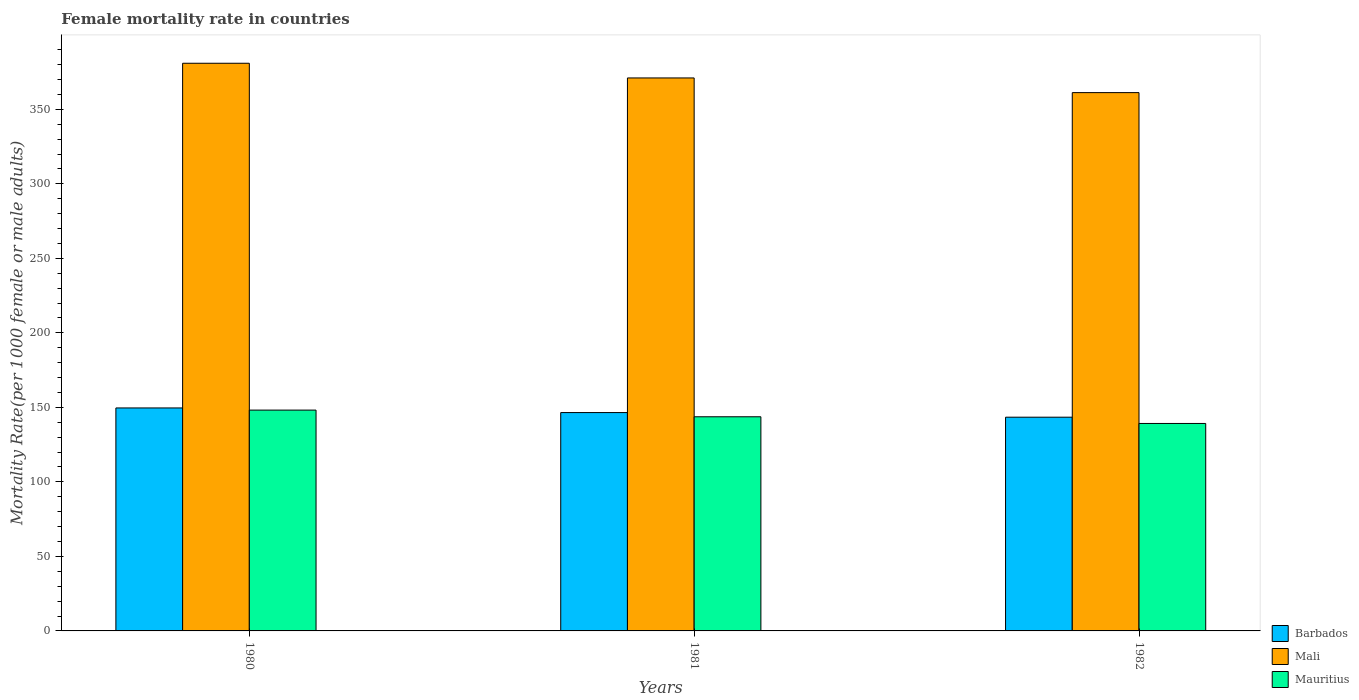How many different coloured bars are there?
Provide a short and direct response. 3. How many groups of bars are there?
Offer a very short reply. 3. How many bars are there on the 2nd tick from the left?
Your response must be concise. 3. How many bars are there on the 2nd tick from the right?
Make the answer very short. 3. What is the label of the 3rd group of bars from the left?
Your response must be concise. 1982. In how many cases, is the number of bars for a given year not equal to the number of legend labels?
Provide a short and direct response. 0. What is the female mortality rate in Mali in 1982?
Your response must be concise. 361.18. Across all years, what is the maximum female mortality rate in Mali?
Ensure brevity in your answer.  380.89. Across all years, what is the minimum female mortality rate in Mali?
Your answer should be compact. 361.18. In which year was the female mortality rate in Mauritius maximum?
Your answer should be compact. 1980. What is the total female mortality rate in Mauritius in the graph?
Make the answer very short. 431.06. What is the difference between the female mortality rate in Mauritius in 1981 and that in 1982?
Keep it short and to the point. 4.48. What is the difference between the female mortality rate in Barbados in 1981 and the female mortality rate in Mali in 1982?
Offer a very short reply. -214.67. What is the average female mortality rate in Mali per year?
Give a very brief answer. 371.04. In the year 1980, what is the difference between the female mortality rate in Barbados and female mortality rate in Mali?
Make the answer very short. -231.28. In how many years, is the female mortality rate in Mali greater than 10?
Offer a terse response. 3. What is the ratio of the female mortality rate in Mali in 1980 to that in 1981?
Provide a succinct answer. 1.03. Is the female mortality rate in Mauritius in 1980 less than that in 1982?
Offer a terse response. No. What is the difference between the highest and the second highest female mortality rate in Mauritius?
Your response must be concise. 4.48. What is the difference between the highest and the lowest female mortality rate in Mauritius?
Offer a terse response. 8.96. In how many years, is the female mortality rate in Mauritius greater than the average female mortality rate in Mauritius taken over all years?
Make the answer very short. 1. What does the 2nd bar from the left in 1981 represents?
Offer a terse response. Mali. What does the 3rd bar from the right in 1981 represents?
Keep it short and to the point. Barbados. Are all the bars in the graph horizontal?
Make the answer very short. No. How many years are there in the graph?
Your answer should be very brief. 3. What is the difference between two consecutive major ticks on the Y-axis?
Provide a short and direct response. 50. Are the values on the major ticks of Y-axis written in scientific E-notation?
Provide a short and direct response. No. Does the graph contain any zero values?
Offer a terse response. No. Where does the legend appear in the graph?
Offer a terse response. Bottom right. How are the legend labels stacked?
Your answer should be very brief. Vertical. What is the title of the graph?
Provide a short and direct response. Female mortality rate in countries. What is the label or title of the Y-axis?
Your answer should be compact. Mortality Rate(per 1000 female or male adults). What is the Mortality Rate(per 1000 female or male adults) of Barbados in 1980?
Provide a short and direct response. 149.61. What is the Mortality Rate(per 1000 female or male adults) in Mali in 1980?
Provide a succinct answer. 380.89. What is the Mortality Rate(per 1000 female or male adults) of Mauritius in 1980?
Keep it short and to the point. 148.17. What is the Mortality Rate(per 1000 female or male adults) of Barbados in 1981?
Keep it short and to the point. 146.51. What is the Mortality Rate(per 1000 female or male adults) of Mali in 1981?
Offer a terse response. 371.04. What is the Mortality Rate(per 1000 female or male adults) of Mauritius in 1981?
Offer a terse response. 143.69. What is the Mortality Rate(per 1000 female or male adults) in Barbados in 1982?
Make the answer very short. 143.4. What is the Mortality Rate(per 1000 female or male adults) in Mali in 1982?
Make the answer very short. 361.18. What is the Mortality Rate(per 1000 female or male adults) of Mauritius in 1982?
Your answer should be compact. 139.2. Across all years, what is the maximum Mortality Rate(per 1000 female or male adults) in Barbados?
Keep it short and to the point. 149.61. Across all years, what is the maximum Mortality Rate(per 1000 female or male adults) of Mali?
Keep it short and to the point. 380.89. Across all years, what is the maximum Mortality Rate(per 1000 female or male adults) of Mauritius?
Your response must be concise. 148.17. Across all years, what is the minimum Mortality Rate(per 1000 female or male adults) of Barbados?
Give a very brief answer. 143.4. Across all years, what is the minimum Mortality Rate(per 1000 female or male adults) in Mali?
Provide a short and direct response. 361.18. Across all years, what is the minimum Mortality Rate(per 1000 female or male adults) of Mauritius?
Ensure brevity in your answer.  139.2. What is the total Mortality Rate(per 1000 female or male adults) of Barbados in the graph?
Your response must be concise. 439.52. What is the total Mortality Rate(per 1000 female or male adults) in Mali in the graph?
Ensure brevity in your answer.  1113.11. What is the total Mortality Rate(per 1000 female or male adults) in Mauritius in the graph?
Give a very brief answer. 431.06. What is the difference between the Mortality Rate(per 1000 female or male adults) of Barbados in 1980 and that in 1981?
Your answer should be very brief. 3.1. What is the difference between the Mortality Rate(per 1000 female or male adults) in Mali in 1980 and that in 1981?
Your answer should be very brief. 9.85. What is the difference between the Mortality Rate(per 1000 female or male adults) in Mauritius in 1980 and that in 1981?
Your answer should be very brief. 4.48. What is the difference between the Mortality Rate(per 1000 female or male adults) of Barbados in 1980 and that in 1982?
Keep it short and to the point. 6.21. What is the difference between the Mortality Rate(per 1000 female or male adults) of Mali in 1980 and that in 1982?
Give a very brief answer. 19.7. What is the difference between the Mortality Rate(per 1000 female or male adults) in Mauritius in 1980 and that in 1982?
Make the answer very short. 8.96. What is the difference between the Mortality Rate(per 1000 female or male adults) of Barbados in 1981 and that in 1982?
Provide a short and direct response. 3.1. What is the difference between the Mortality Rate(per 1000 female or male adults) in Mali in 1981 and that in 1982?
Make the answer very short. 9.85. What is the difference between the Mortality Rate(per 1000 female or male adults) of Mauritius in 1981 and that in 1982?
Your answer should be compact. 4.48. What is the difference between the Mortality Rate(per 1000 female or male adults) in Barbados in 1980 and the Mortality Rate(per 1000 female or male adults) in Mali in 1981?
Give a very brief answer. -221.42. What is the difference between the Mortality Rate(per 1000 female or male adults) of Barbados in 1980 and the Mortality Rate(per 1000 female or male adults) of Mauritius in 1981?
Give a very brief answer. 5.93. What is the difference between the Mortality Rate(per 1000 female or male adults) of Mali in 1980 and the Mortality Rate(per 1000 female or male adults) of Mauritius in 1981?
Provide a succinct answer. 237.2. What is the difference between the Mortality Rate(per 1000 female or male adults) in Barbados in 1980 and the Mortality Rate(per 1000 female or male adults) in Mali in 1982?
Your answer should be very brief. -211.57. What is the difference between the Mortality Rate(per 1000 female or male adults) in Barbados in 1980 and the Mortality Rate(per 1000 female or male adults) in Mauritius in 1982?
Provide a succinct answer. 10.41. What is the difference between the Mortality Rate(per 1000 female or male adults) in Mali in 1980 and the Mortality Rate(per 1000 female or male adults) in Mauritius in 1982?
Provide a short and direct response. 241.68. What is the difference between the Mortality Rate(per 1000 female or male adults) of Barbados in 1981 and the Mortality Rate(per 1000 female or male adults) of Mali in 1982?
Provide a short and direct response. -214.68. What is the difference between the Mortality Rate(per 1000 female or male adults) of Barbados in 1981 and the Mortality Rate(per 1000 female or male adults) of Mauritius in 1982?
Give a very brief answer. 7.3. What is the difference between the Mortality Rate(per 1000 female or male adults) of Mali in 1981 and the Mortality Rate(per 1000 female or male adults) of Mauritius in 1982?
Ensure brevity in your answer.  231.83. What is the average Mortality Rate(per 1000 female or male adults) in Barbados per year?
Your answer should be compact. 146.51. What is the average Mortality Rate(per 1000 female or male adults) in Mali per year?
Give a very brief answer. 371.04. What is the average Mortality Rate(per 1000 female or male adults) in Mauritius per year?
Ensure brevity in your answer.  143.69. In the year 1980, what is the difference between the Mortality Rate(per 1000 female or male adults) of Barbados and Mortality Rate(per 1000 female or male adults) of Mali?
Provide a short and direct response. -231.28. In the year 1980, what is the difference between the Mortality Rate(per 1000 female or male adults) of Barbados and Mortality Rate(per 1000 female or male adults) of Mauritius?
Your response must be concise. 1.45. In the year 1980, what is the difference between the Mortality Rate(per 1000 female or male adults) of Mali and Mortality Rate(per 1000 female or male adults) of Mauritius?
Provide a short and direct response. 232.72. In the year 1981, what is the difference between the Mortality Rate(per 1000 female or male adults) of Barbados and Mortality Rate(per 1000 female or male adults) of Mali?
Provide a short and direct response. -224.53. In the year 1981, what is the difference between the Mortality Rate(per 1000 female or male adults) of Barbados and Mortality Rate(per 1000 female or male adults) of Mauritius?
Give a very brief answer. 2.82. In the year 1981, what is the difference between the Mortality Rate(per 1000 female or male adults) of Mali and Mortality Rate(per 1000 female or male adults) of Mauritius?
Your answer should be very brief. 227.35. In the year 1982, what is the difference between the Mortality Rate(per 1000 female or male adults) in Barbados and Mortality Rate(per 1000 female or male adults) in Mali?
Offer a very short reply. -217.78. In the year 1982, what is the difference between the Mortality Rate(per 1000 female or male adults) of Mali and Mortality Rate(per 1000 female or male adults) of Mauritius?
Offer a terse response. 221.98. What is the ratio of the Mortality Rate(per 1000 female or male adults) in Barbados in 1980 to that in 1981?
Your answer should be compact. 1.02. What is the ratio of the Mortality Rate(per 1000 female or male adults) in Mali in 1980 to that in 1981?
Give a very brief answer. 1.03. What is the ratio of the Mortality Rate(per 1000 female or male adults) in Mauritius in 1980 to that in 1981?
Make the answer very short. 1.03. What is the ratio of the Mortality Rate(per 1000 female or male adults) in Barbados in 1980 to that in 1982?
Make the answer very short. 1.04. What is the ratio of the Mortality Rate(per 1000 female or male adults) in Mali in 1980 to that in 1982?
Offer a very short reply. 1.05. What is the ratio of the Mortality Rate(per 1000 female or male adults) in Mauritius in 1980 to that in 1982?
Offer a terse response. 1.06. What is the ratio of the Mortality Rate(per 1000 female or male adults) of Barbados in 1981 to that in 1982?
Provide a short and direct response. 1.02. What is the ratio of the Mortality Rate(per 1000 female or male adults) in Mali in 1981 to that in 1982?
Keep it short and to the point. 1.03. What is the ratio of the Mortality Rate(per 1000 female or male adults) of Mauritius in 1981 to that in 1982?
Offer a terse response. 1.03. What is the difference between the highest and the second highest Mortality Rate(per 1000 female or male adults) in Barbados?
Your answer should be compact. 3.1. What is the difference between the highest and the second highest Mortality Rate(per 1000 female or male adults) of Mali?
Give a very brief answer. 9.85. What is the difference between the highest and the second highest Mortality Rate(per 1000 female or male adults) of Mauritius?
Make the answer very short. 4.48. What is the difference between the highest and the lowest Mortality Rate(per 1000 female or male adults) in Barbados?
Ensure brevity in your answer.  6.21. What is the difference between the highest and the lowest Mortality Rate(per 1000 female or male adults) of Mali?
Your answer should be compact. 19.7. What is the difference between the highest and the lowest Mortality Rate(per 1000 female or male adults) in Mauritius?
Provide a succinct answer. 8.96. 